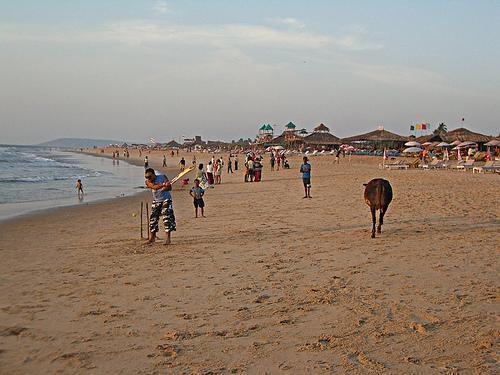How many horses?
Give a very brief answer. 1. How many brown horses are there?
Give a very brief answer. 1. How many buses are shown?
Give a very brief answer. 0. 